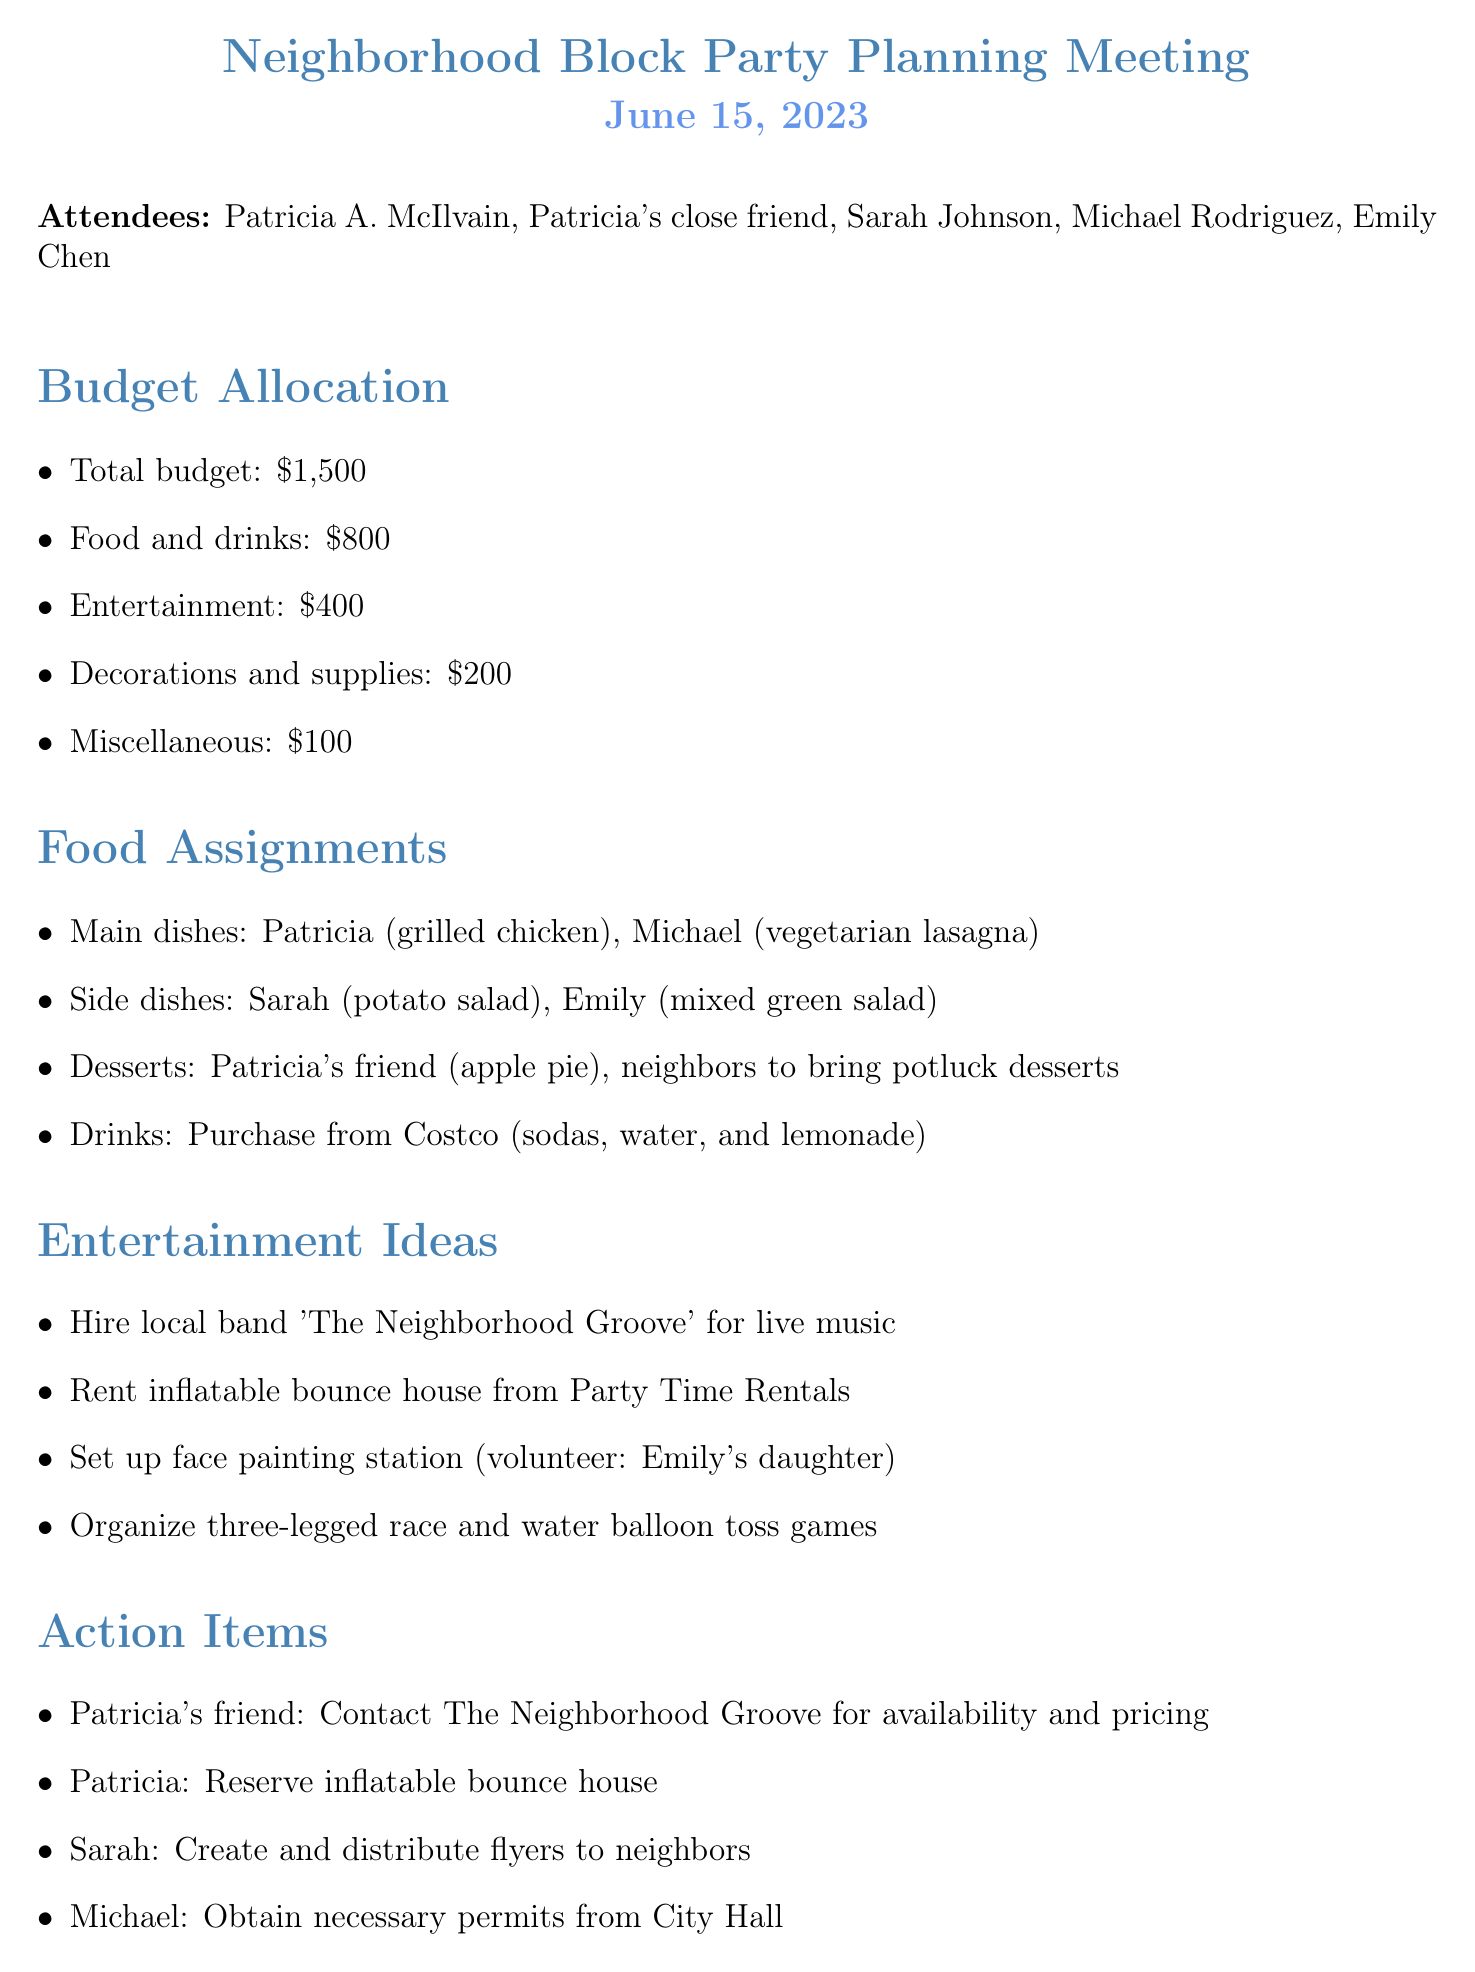What is the total budget for the block party? The budget is explicitly listed in the document under the Budget Allocation section.
Answer: $1,500 Who is responsible for the main dish of grilled chicken? This information is specified under Food Assignments, where individuals are assigned dishes.
Answer: Patricia How much is allocated for entertainment? The amount is stated in the Budget Allocation section, providing a breakdown of expenses.
Answer: $400 What dessert will you be bringing? The dessert assignment is mentioned in the Food Assignments section, listing your contribution.
Answer: Apple pie When is the next meeting scheduled? The date and time of the next meeting are documented at the end of the minutes.
Answer: July 1, 2023, 7:00 PM What volunteer role did Emily's daughter take? This is noted under the Entertainment Ideas section, where volunteer roles are outlined.
Answer: Face painting station Who will create and distribute flyers? The action item for the flyer distribution is stated in the Action Items section, indicating responsibilities.
Answer: Sarah What type of entertainment is being proposed? Various forms of entertainment are listed in the Entertainment Ideas section, indicating activities planned for the event.
Answer: Live music, inflatable bounce house, face painting, games How much is allocated for decorations and supplies? The specific allocation is clearly outlined in the Budget Allocation section under various expense categories.
Answer: $200 